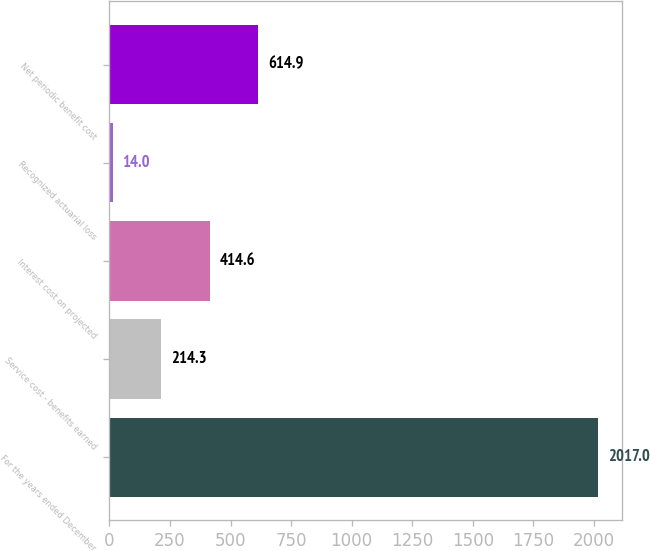Convert chart. <chart><loc_0><loc_0><loc_500><loc_500><bar_chart><fcel>For the years ended December<fcel>Service cost - benefits earned<fcel>Interest cost on projected<fcel>Recognized actuarial loss<fcel>Net periodic benefit cost<nl><fcel>2017<fcel>214.3<fcel>414.6<fcel>14<fcel>614.9<nl></chart> 